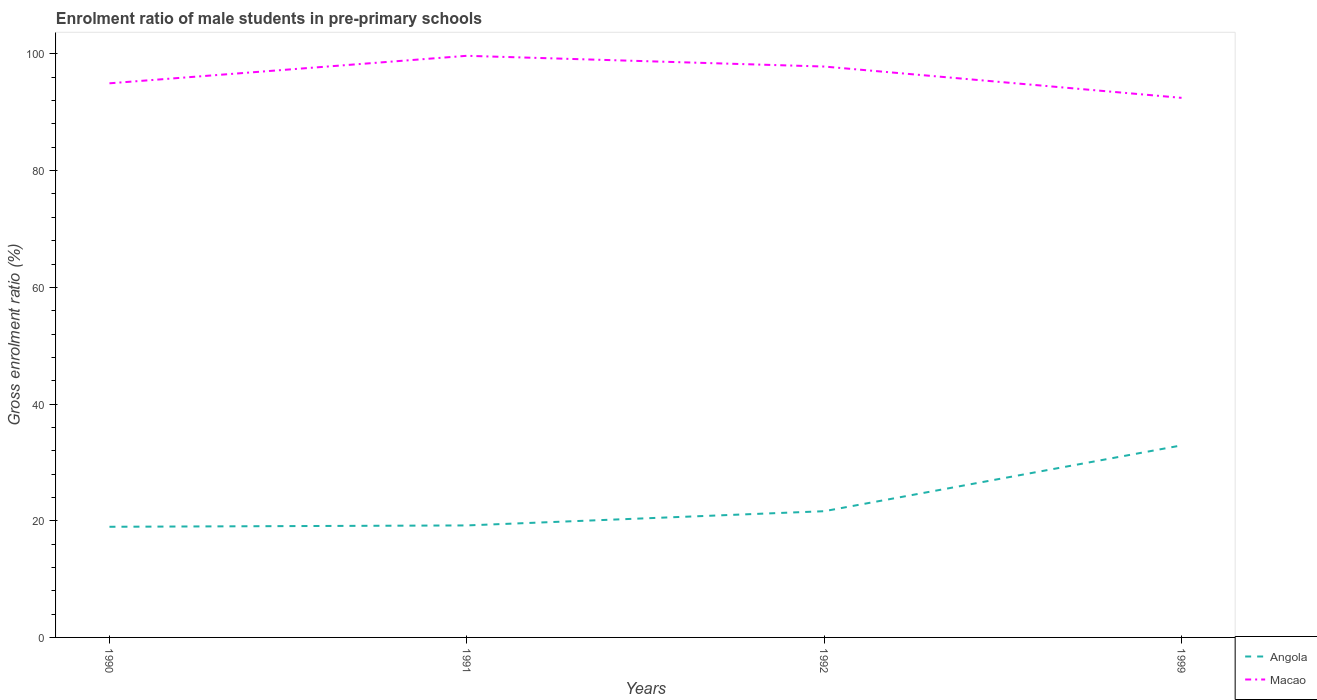How many different coloured lines are there?
Keep it short and to the point. 2. Is the number of lines equal to the number of legend labels?
Keep it short and to the point. Yes. Across all years, what is the maximum enrolment ratio of male students in pre-primary schools in Macao?
Ensure brevity in your answer.  92.48. What is the total enrolment ratio of male students in pre-primary schools in Angola in the graph?
Give a very brief answer. -2.44. What is the difference between the highest and the second highest enrolment ratio of male students in pre-primary schools in Angola?
Make the answer very short. 13.95. What is the difference between the highest and the lowest enrolment ratio of male students in pre-primary schools in Macao?
Provide a succinct answer. 2. What is the difference between two consecutive major ticks on the Y-axis?
Make the answer very short. 20. Does the graph contain grids?
Give a very brief answer. No. How many legend labels are there?
Provide a succinct answer. 2. How are the legend labels stacked?
Your answer should be compact. Vertical. What is the title of the graph?
Provide a short and direct response. Enrolment ratio of male students in pre-primary schools. What is the label or title of the Y-axis?
Provide a succinct answer. Gross enrolment ratio (%). What is the Gross enrolment ratio (%) in Angola in 1990?
Offer a very short reply. 18.96. What is the Gross enrolment ratio (%) in Macao in 1990?
Your answer should be very brief. 94.97. What is the Gross enrolment ratio (%) in Angola in 1991?
Give a very brief answer. 19.2. What is the Gross enrolment ratio (%) in Macao in 1991?
Keep it short and to the point. 99.68. What is the Gross enrolment ratio (%) of Angola in 1992?
Offer a terse response. 21.63. What is the Gross enrolment ratio (%) of Macao in 1992?
Provide a succinct answer. 97.84. What is the Gross enrolment ratio (%) of Angola in 1999?
Offer a terse response. 32.92. What is the Gross enrolment ratio (%) in Macao in 1999?
Your answer should be very brief. 92.48. Across all years, what is the maximum Gross enrolment ratio (%) of Angola?
Your answer should be compact. 32.92. Across all years, what is the maximum Gross enrolment ratio (%) in Macao?
Ensure brevity in your answer.  99.68. Across all years, what is the minimum Gross enrolment ratio (%) of Angola?
Give a very brief answer. 18.96. Across all years, what is the minimum Gross enrolment ratio (%) of Macao?
Your answer should be very brief. 92.48. What is the total Gross enrolment ratio (%) of Angola in the graph?
Keep it short and to the point. 92.71. What is the total Gross enrolment ratio (%) of Macao in the graph?
Ensure brevity in your answer.  384.97. What is the difference between the Gross enrolment ratio (%) in Angola in 1990 and that in 1991?
Your answer should be compact. -0.23. What is the difference between the Gross enrolment ratio (%) in Macao in 1990 and that in 1991?
Offer a very short reply. -4.71. What is the difference between the Gross enrolment ratio (%) of Angola in 1990 and that in 1992?
Your answer should be very brief. -2.67. What is the difference between the Gross enrolment ratio (%) in Macao in 1990 and that in 1992?
Offer a very short reply. -2.87. What is the difference between the Gross enrolment ratio (%) of Angola in 1990 and that in 1999?
Ensure brevity in your answer.  -13.95. What is the difference between the Gross enrolment ratio (%) of Macao in 1990 and that in 1999?
Offer a very short reply. 2.49. What is the difference between the Gross enrolment ratio (%) in Angola in 1991 and that in 1992?
Provide a short and direct response. -2.44. What is the difference between the Gross enrolment ratio (%) of Macao in 1991 and that in 1992?
Provide a succinct answer. 1.84. What is the difference between the Gross enrolment ratio (%) of Angola in 1991 and that in 1999?
Your answer should be very brief. -13.72. What is the difference between the Gross enrolment ratio (%) in Macao in 1991 and that in 1999?
Your answer should be compact. 7.21. What is the difference between the Gross enrolment ratio (%) in Angola in 1992 and that in 1999?
Offer a terse response. -11.28. What is the difference between the Gross enrolment ratio (%) in Macao in 1992 and that in 1999?
Ensure brevity in your answer.  5.36. What is the difference between the Gross enrolment ratio (%) in Angola in 1990 and the Gross enrolment ratio (%) in Macao in 1991?
Offer a terse response. -80.72. What is the difference between the Gross enrolment ratio (%) in Angola in 1990 and the Gross enrolment ratio (%) in Macao in 1992?
Provide a succinct answer. -78.88. What is the difference between the Gross enrolment ratio (%) in Angola in 1990 and the Gross enrolment ratio (%) in Macao in 1999?
Your answer should be compact. -73.51. What is the difference between the Gross enrolment ratio (%) in Angola in 1991 and the Gross enrolment ratio (%) in Macao in 1992?
Offer a very short reply. -78.65. What is the difference between the Gross enrolment ratio (%) of Angola in 1991 and the Gross enrolment ratio (%) of Macao in 1999?
Your answer should be very brief. -73.28. What is the difference between the Gross enrolment ratio (%) in Angola in 1992 and the Gross enrolment ratio (%) in Macao in 1999?
Provide a short and direct response. -70.84. What is the average Gross enrolment ratio (%) in Angola per year?
Offer a very short reply. 23.18. What is the average Gross enrolment ratio (%) of Macao per year?
Your answer should be very brief. 96.24. In the year 1990, what is the difference between the Gross enrolment ratio (%) in Angola and Gross enrolment ratio (%) in Macao?
Provide a succinct answer. -76.01. In the year 1991, what is the difference between the Gross enrolment ratio (%) in Angola and Gross enrolment ratio (%) in Macao?
Keep it short and to the point. -80.49. In the year 1992, what is the difference between the Gross enrolment ratio (%) of Angola and Gross enrolment ratio (%) of Macao?
Offer a terse response. -76.21. In the year 1999, what is the difference between the Gross enrolment ratio (%) in Angola and Gross enrolment ratio (%) in Macao?
Give a very brief answer. -59.56. What is the ratio of the Gross enrolment ratio (%) of Macao in 1990 to that in 1991?
Provide a succinct answer. 0.95. What is the ratio of the Gross enrolment ratio (%) of Angola in 1990 to that in 1992?
Your answer should be compact. 0.88. What is the ratio of the Gross enrolment ratio (%) in Macao in 1990 to that in 1992?
Provide a succinct answer. 0.97. What is the ratio of the Gross enrolment ratio (%) of Angola in 1990 to that in 1999?
Provide a short and direct response. 0.58. What is the ratio of the Gross enrolment ratio (%) of Macao in 1990 to that in 1999?
Your response must be concise. 1.03. What is the ratio of the Gross enrolment ratio (%) of Angola in 1991 to that in 1992?
Your response must be concise. 0.89. What is the ratio of the Gross enrolment ratio (%) of Macao in 1991 to that in 1992?
Your answer should be compact. 1.02. What is the ratio of the Gross enrolment ratio (%) in Angola in 1991 to that in 1999?
Ensure brevity in your answer.  0.58. What is the ratio of the Gross enrolment ratio (%) in Macao in 1991 to that in 1999?
Your answer should be very brief. 1.08. What is the ratio of the Gross enrolment ratio (%) of Angola in 1992 to that in 1999?
Your answer should be very brief. 0.66. What is the ratio of the Gross enrolment ratio (%) in Macao in 1992 to that in 1999?
Make the answer very short. 1.06. What is the difference between the highest and the second highest Gross enrolment ratio (%) of Angola?
Offer a very short reply. 11.28. What is the difference between the highest and the second highest Gross enrolment ratio (%) of Macao?
Ensure brevity in your answer.  1.84. What is the difference between the highest and the lowest Gross enrolment ratio (%) in Angola?
Keep it short and to the point. 13.95. What is the difference between the highest and the lowest Gross enrolment ratio (%) in Macao?
Ensure brevity in your answer.  7.21. 